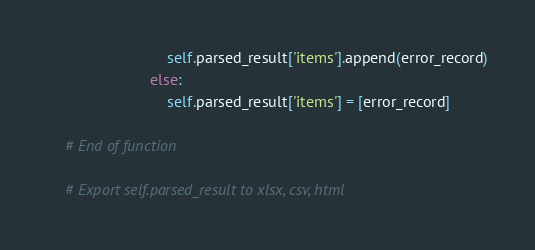Convert code to text. <code><loc_0><loc_0><loc_500><loc_500><_Python_>                            self.parsed_result['items'].append(error_record)
                        else:
                            self.parsed_result['items'] = [error_record]

    # End of function

    # Export self.parsed_result to xlsx, csv, html</code> 